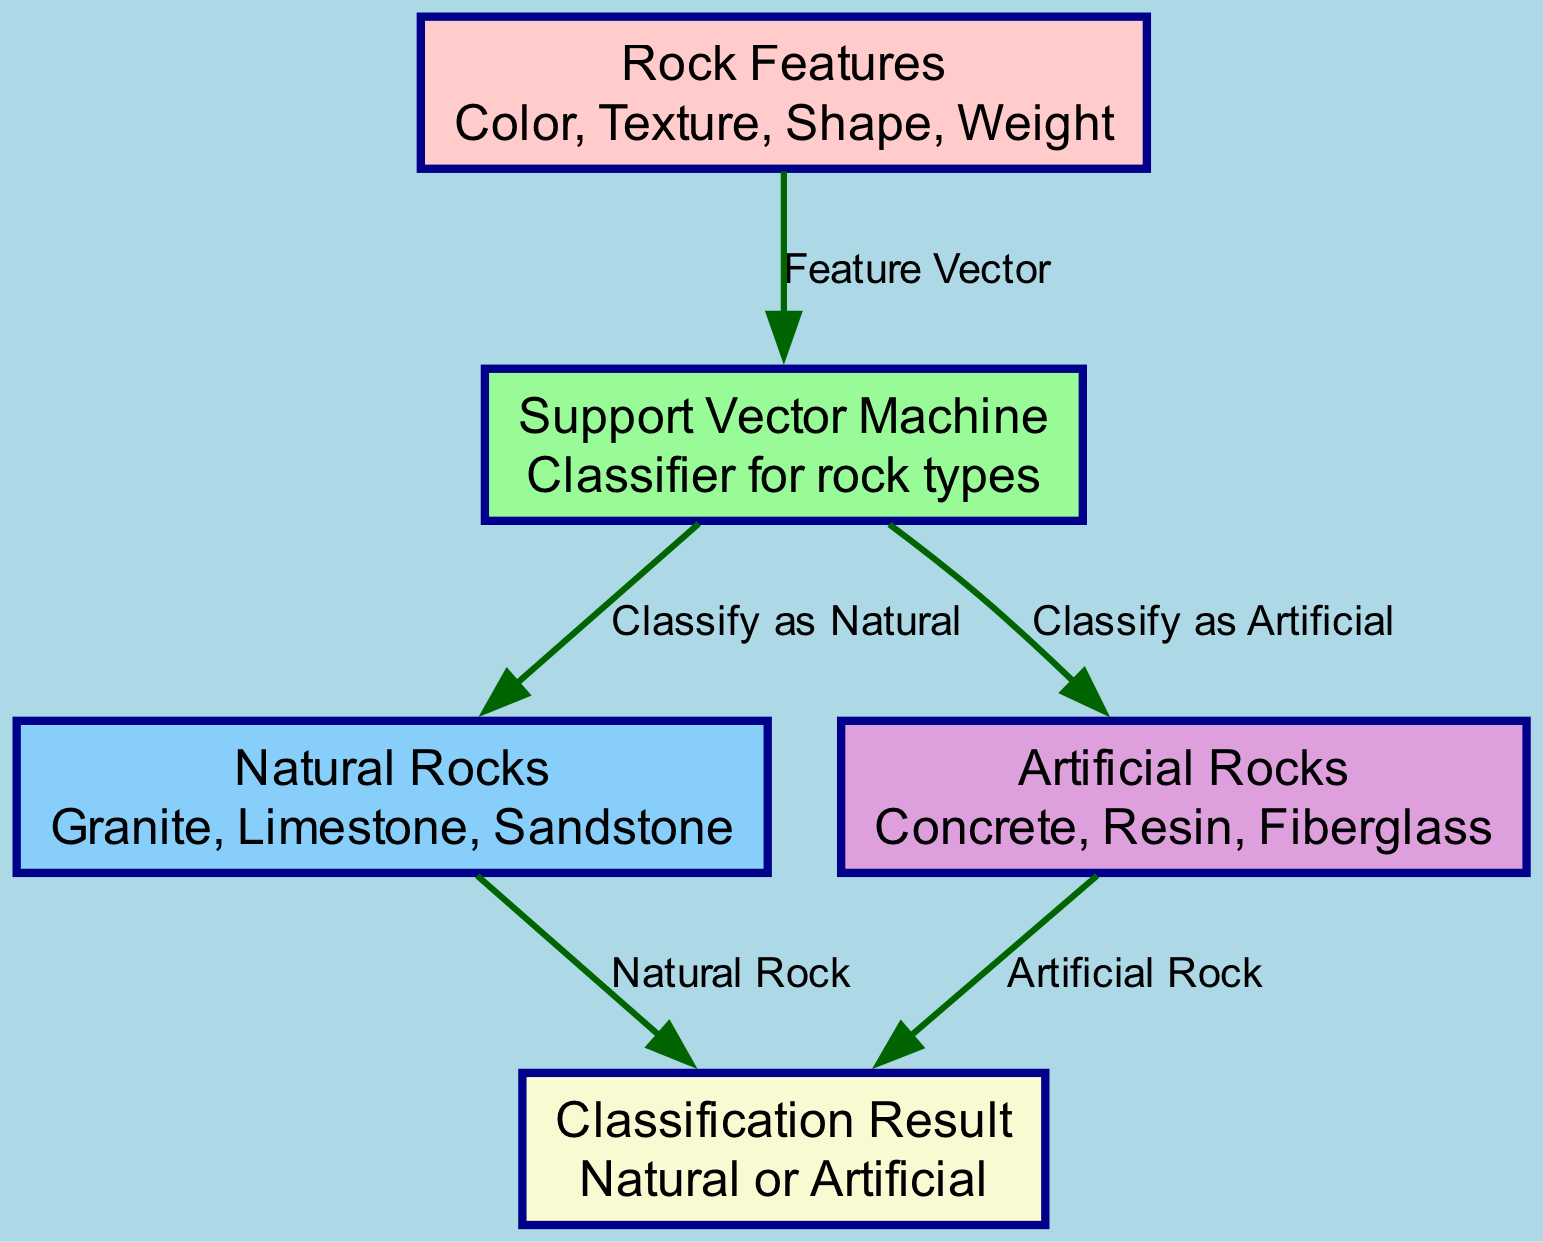What are the features used for classification in the input node? The input node lists the features used for classification as Color, Texture, Shape, and Weight. This is a direct observation from the node labeled "Rock Features".
Answer: Color, Texture, Shape, Weight How many types of rocks are classified by the support vector machine? The support vector machine classifies two types of rocks: Natural and Artificial. This information can be derived by examining the edges connected to the "Support Vector Machine" node that lead to "Natural Rocks" and "Artificial Rocks".
Answer: Two What is the classification result if a rock is classified as natural? If a rock is classified as Natural, the resulting classification is "Natural Rock", as indicated by the edge labeled "Natural Rock" leading to the "Classification Result" node.
Answer: Natural Rock What connects the input of features to the support vector machine? The "Feature Vector" edge connects the input of features (from the "Rock Features" node) to the support vector machine (the "Support Vector Machine" node). This can be seen in the labeled edge originating from "Rock Features" to "Support Vector Machine".
Answer: Feature Vector Which node would you arrive at if the classification is determined to be artificial? If the classification is determined to be artificial, you would arrive at the "Artificial Rock" node, which is connected to the "Support Vector Machine" node by the edge labeled "Classify as Artificial".
Answer: Artificial Rock What color is assigned to the node representing artificial rocks? The node representing artificial rocks is assigned the color Plum, which is indicated in the diagram by the corresponding color legend for the "Artificial Rocks" node.
Answer: Plum How many edges are there leaving the support vector machine node? The support vector machine node has two edges leaving it: one to "Natural Rocks" and one to "Artificial Rocks". This can be counted directly from the edges originating from the "Support Vector Machine" node.
Answer: Two What label is given for the connection of natural rocks to the classification result? The label given for the connection from natural rocks to the classification result is "Natural Rock". This can be seen in the diagram where the edge from "Natural Rocks" leads to the "Classification Result" node.
Answer: Natural Rock Which node represents artificial rocks? The node representing artificial rocks is labeled "Artificial Rocks". This is a straightforward identification from the corresponding node in the diagram.
Answer: Artificial Rocks 